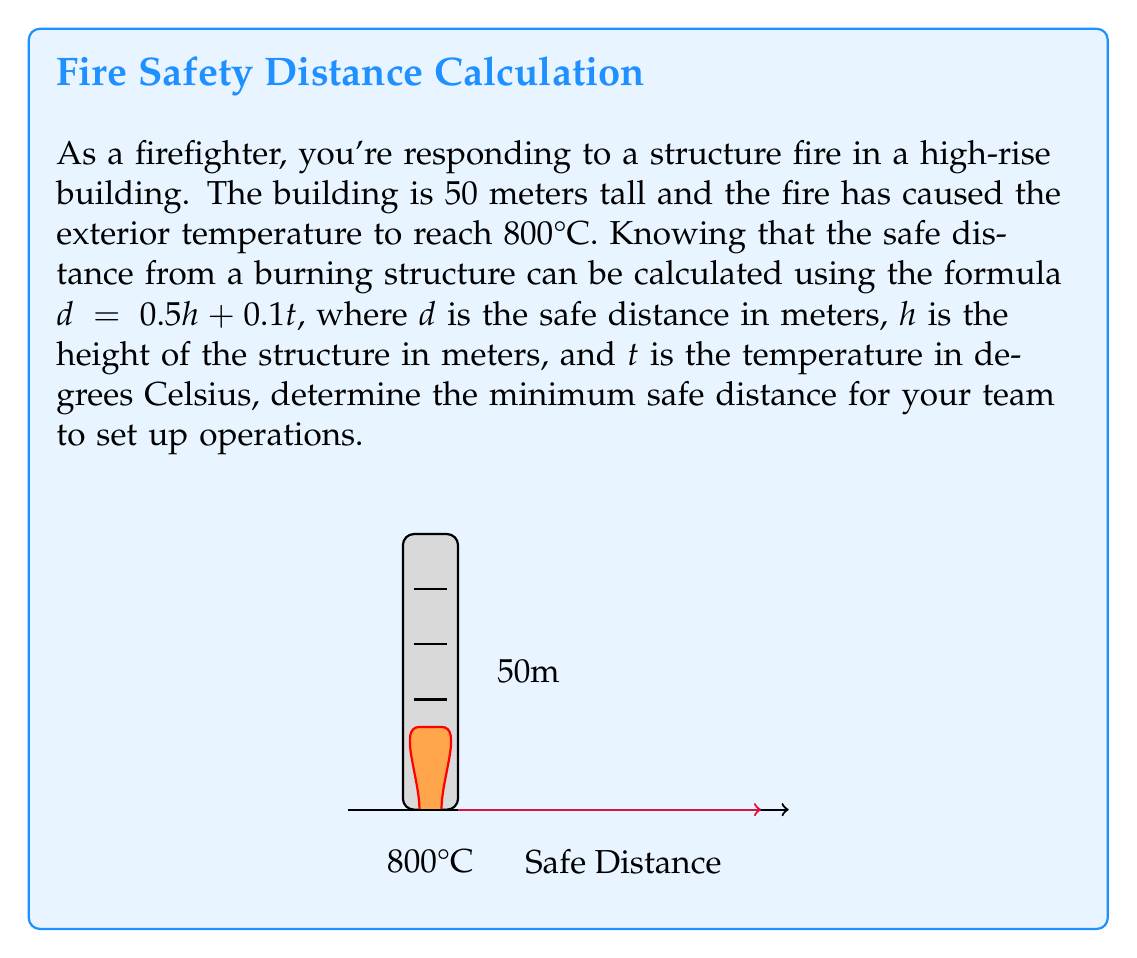Give your solution to this math problem. To solve this problem, we'll use the given formula and substitute the known values:

1) The formula for safe distance is:
   $d = 0.5h + 0.1t$

2) We know:
   $h = 50$ meters (height of the building)
   $t = 800°C$ (temperature of the fire)

3) Let's substitute these values into the formula:
   $d = 0.5(50) + 0.1(800)$

4) First, calculate the height component:
   $0.5(50) = 25$ meters

5) Next, calculate the temperature component:
   $0.1(800) = 80$ meters

6) Now, add these components together:
   $d = 25 + 80 = 105$ meters

Therefore, the minimum safe distance for the firefighting team to set up operations is 105 meters from the burning structure.
Answer: $105$ meters 